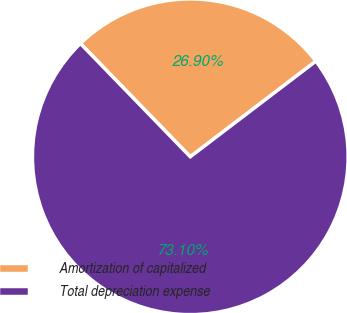Convert chart. <chart><loc_0><loc_0><loc_500><loc_500><pie_chart><fcel>Amortization of capitalized<fcel>Total depreciation expense<nl><fcel>26.9%<fcel>73.1%<nl></chart> 